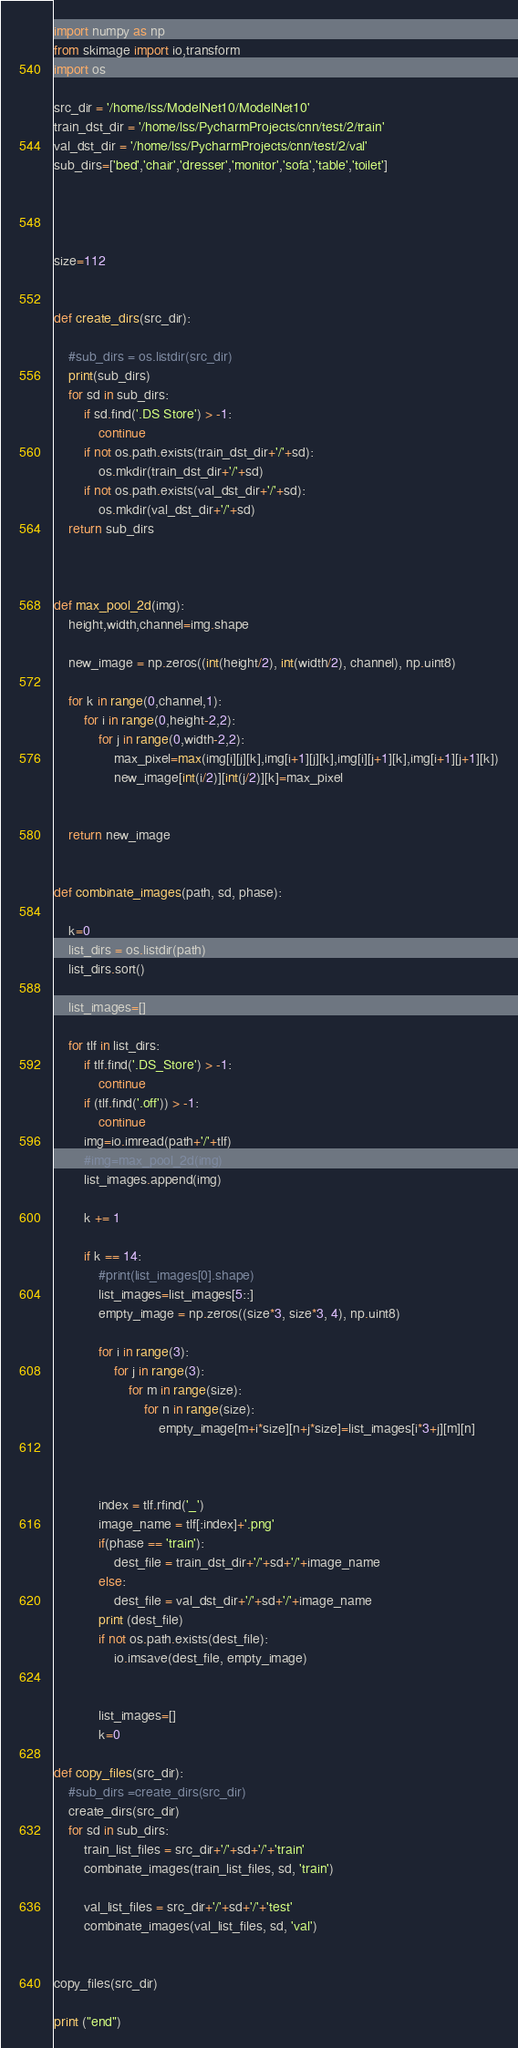<code> <loc_0><loc_0><loc_500><loc_500><_Python_>import numpy as np
from skimage import io,transform
import os

src_dir = '/home/lss/ModelNet10/ModelNet10'
train_dst_dir = '/home/lss/PycharmProjects/cnn/test/2/train'
val_dst_dir = '/home/lss/PycharmProjects/cnn/test/2/val'
sub_dirs=['bed','chair','dresser','monitor','sofa','table','toilet']




size=112


def create_dirs(src_dir):

    #sub_dirs = os.listdir(src_dir)
    print(sub_dirs)
    for sd in sub_dirs:
        if sd.find('.DS Store') > -1:
            continue
        if not os.path.exists(train_dst_dir+'/'+sd):
            os.mkdir(train_dst_dir+'/'+sd)
        if not os.path.exists(val_dst_dir+'/'+sd):
            os.mkdir(val_dst_dir+'/'+sd)
    return sub_dirs



def max_pool_2d(img):
    height,width,channel=img.shape

    new_image = np.zeros((int(height/2), int(width/2), channel), np.uint8)

    for k in range(0,channel,1):
        for i in range(0,height-2,2):
            for j in range(0,width-2,2):
                max_pixel=max(img[i][j][k],img[i+1][j][k],img[i][j+1][k],img[i+1][j+1][k])
                new_image[int(i/2)][int(j/2)][k]=max_pixel
            

    return new_image


def combinate_images(path, sd, phase):

    k=0
    list_dirs = os.listdir(path)
    list_dirs.sort()

    list_images=[]

    for tlf in list_dirs:
        if tlf.find('.DS_Store') > -1:
            continue
        if (tlf.find('.off')) > -1:
            continue
        img=io.imread(path+'/'+tlf)
        #img=max_pool_2d(img)
        list_images.append(img)

        k += 1

        if k == 14:
            #print(list_images[0].shape)
            list_images=list_images[5::]
            empty_image = np.zeros((size*3, size*3, 4), np.uint8)
            
            for i in range(3):
                for j in range(3):
                    for m in range(size):
                        for n in range(size):
                            empty_image[m+i*size][n+j*size]=list_images[i*3+j][m][n]
            
            
            
            index = tlf.rfind('_')
            image_name = tlf[:index]+'.png'
            if(phase == 'train'):
                dest_file = train_dst_dir+'/'+sd+'/'+image_name
            else:
                dest_file = val_dst_dir+'/'+sd+'/'+image_name
            print (dest_file)
            if not os.path.exists(dest_file):
                io.imsave(dest_file, empty_image)


            list_images=[]
            k=0

def copy_files(src_dir):
    #sub_dirs =create_dirs(src_dir)
    create_dirs(src_dir)
    for sd in sub_dirs:
        train_list_files = src_dir+'/'+sd+'/'+'train'
        combinate_images(train_list_files, sd, 'train')

        val_list_files = src_dir+'/'+sd+'/'+'test'
        combinate_images(val_list_files, sd, 'val')


copy_files(src_dir)

print ("end")










</code> 